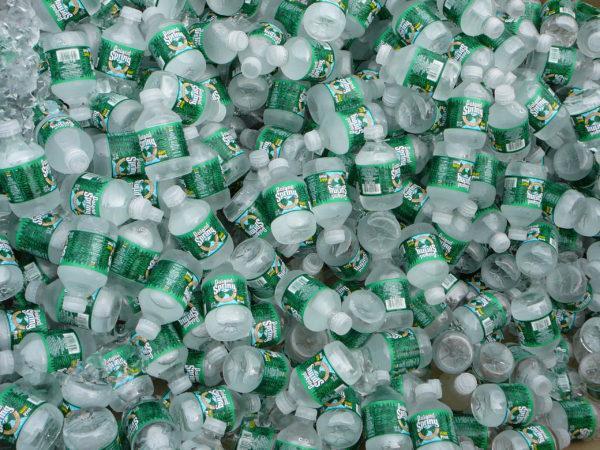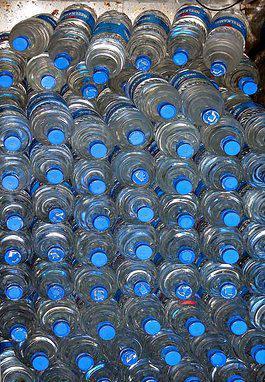The first image is the image on the left, the second image is the image on the right. Examine the images to the left and right. Is the description "An image shows water that is not inside a bottle." accurate? Answer yes or no. No. 